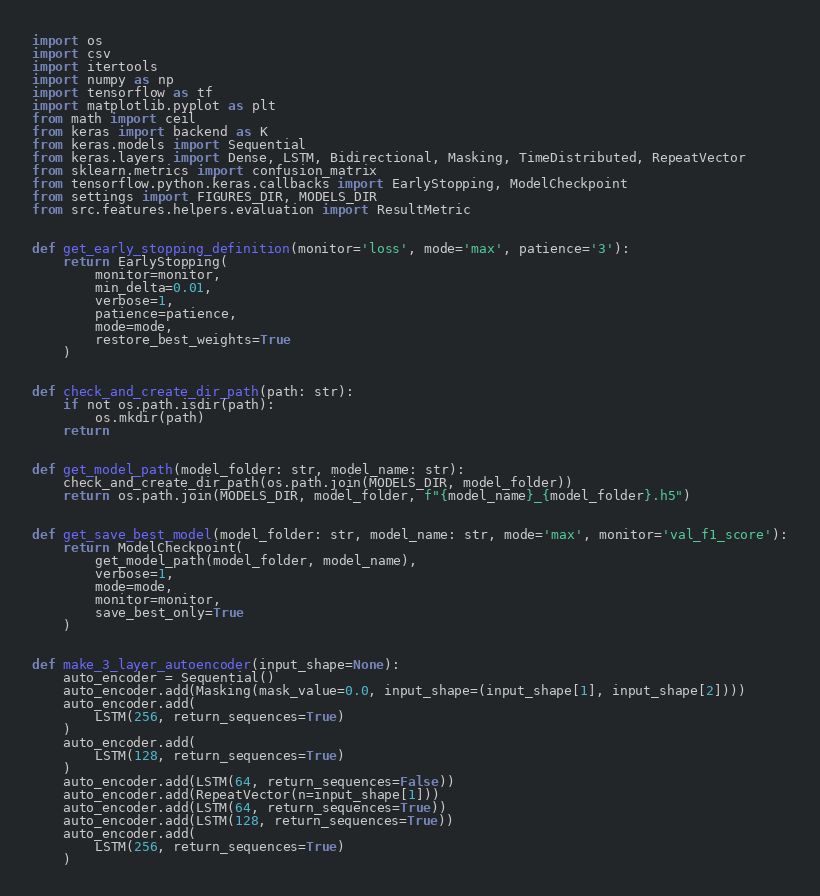<code> <loc_0><loc_0><loc_500><loc_500><_Python_>import os
import csv
import itertools
import numpy as np
import tensorflow as tf
import matplotlib.pyplot as plt
from math import ceil
from keras import backend as K
from keras.models import Sequential
from keras.layers import Dense, LSTM, Bidirectional, Masking, TimeDistributed, RepeatVector
from sklearn.metrics import confusion_matrix
from tensorflow.python.keras.callbacks import EarlyStopping, ModelCheckpoint
from settings import FIGURES_DIR, MODELS_DIR
from src.features.helpers.evaluation import ResultMetric


def get_early_stopping_definition(monitor='loss', mode='max', patience='3'):
    return EarlyStopping(
        monitor=monitor,
        min_delta=0.01,
        verbose=1,
        patience=patience,
        mode=mode,
        restore_best_weights=True
    )


def check_and_create_dir_path(path: str):
    if not os.path.isdir(path):
        os.mkdir(path)
    return


def get_model_path(model_folder: str, model_name: str):
    check_and_create_dir_path(os.path.join(MODELS_DIR, model_folder))
    return os.path.join(MODELS_DIR, model_folder, f"{model_name}_{model_folder}.h5")


def get_save_best_model(model_folder: str, model_name: str, mode='max', monitor='val_f1_score'):
    return ModelCheckpoint(
        get_model_path(model_folder, model_name),
        verbose=1,
        mode=mode,
        monitor=monitor,
        save_best_only=True
    )


def make_3_layer_autoencoder(input_shape=None):
    auto_encoder = Sequential()
    auto_encoder.add(Masking(mask_value=0.0, input_shape=(input_shape[1], input_shape[2])))
    auto_encoder.add(
        LSTM(256, return_sequences=True)
    )
    auto_encoder.add(
        LSTM(128, return_sequences=True)
    )
    auto_encoder.add(LSTM(64, return_sequences=False))
    auto_encoder.add(RepeatVector(n=input_shape[1]))
    auto_encoder.add(LSTM(64, return_sequences=True))
    auto_encoder.add(LSTM(128, return_sequences=True))
    auto_encoder.add(
        LSTM(256, return_sequences=True)
    )</code> 